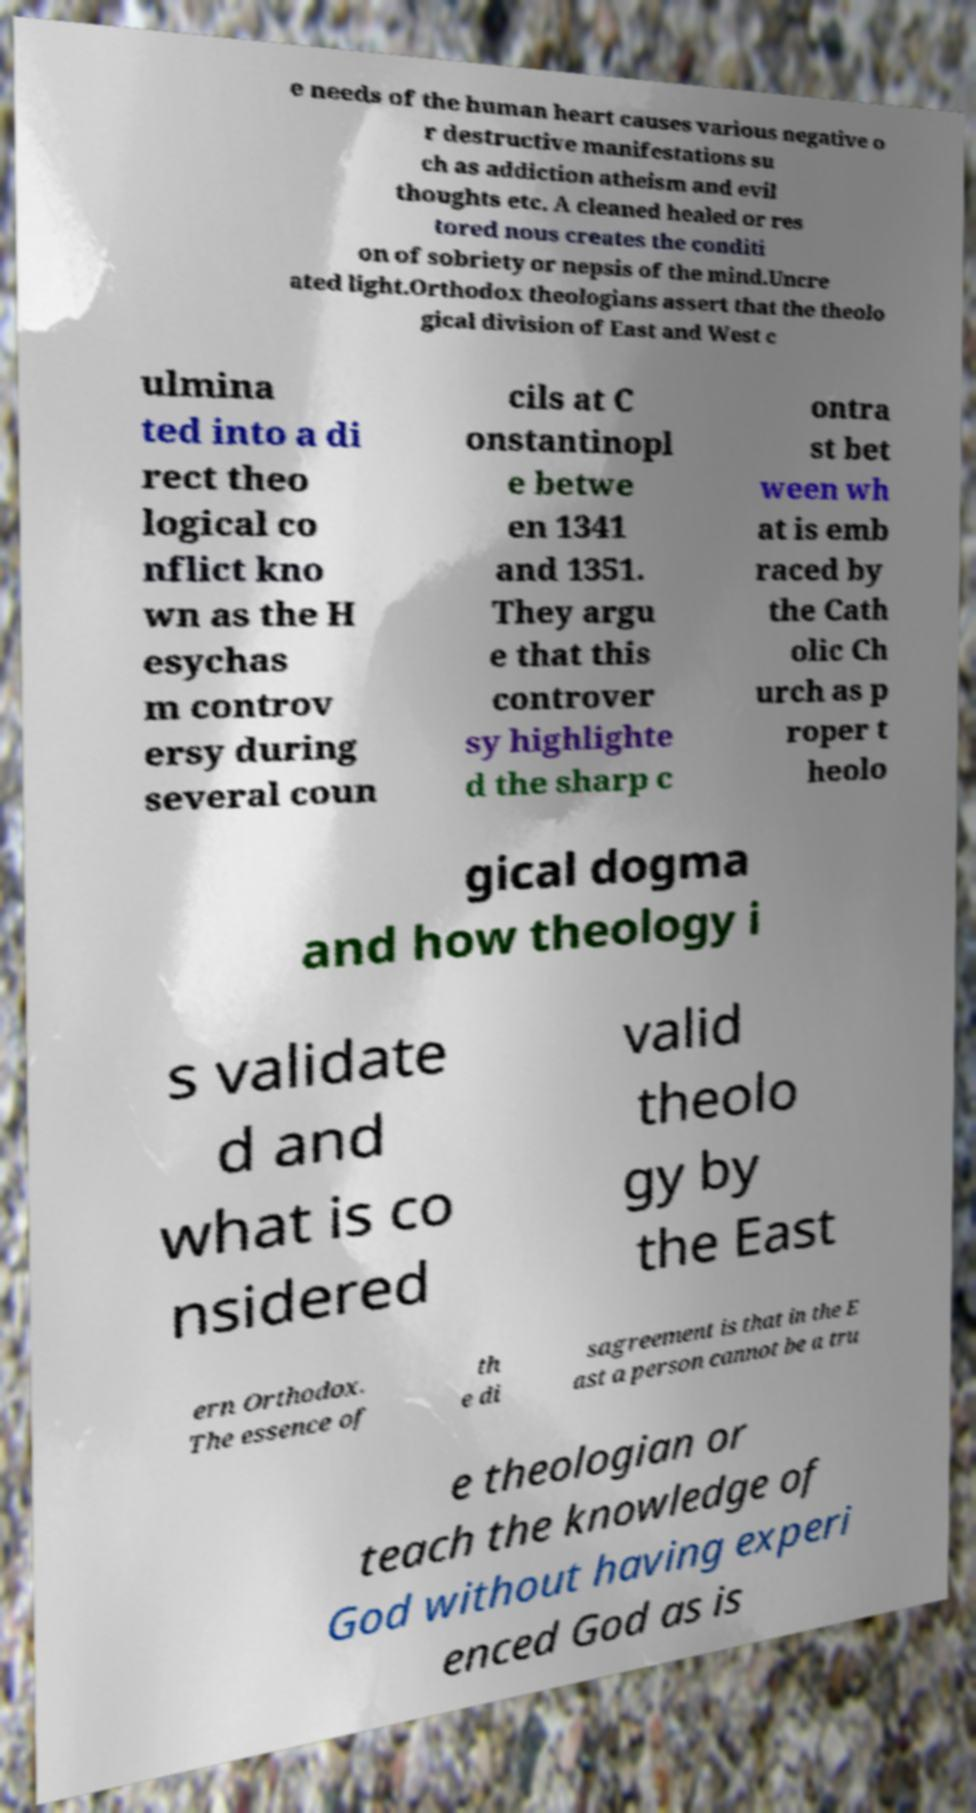What messages or text are displayed in this image? I need them in a readable, typed format. e needs of the human heart causes various negative o r destructive manifestations su ch as addiction atheism and evil thoughts etc. A cleaned healed or res tored nous creates the conditi on of sobriety or nepsis of the mind.Uncre ated light.Orthodox theologians assert that the theolo gical division of East and West c ulmina ted into a di rect theo logical co nflict kno wn as the H esychas m controv ersy during several coun cils at C onstantinopl e betwe en 1341 and 1351. They argu e that this controver sy highlighte d the sharp c ontra st bet ween wh at is emb raced by the Cath olic Ch urch as p roper t heolo gical dogma and how theology i s validate d and what is co nsidered valid theolo gy by the East ern Orthodox. The essence of th e di sagreement is that in the E ast a person cannot be a tru e theologian or teach the knowledge of God without having experi enced God as is 